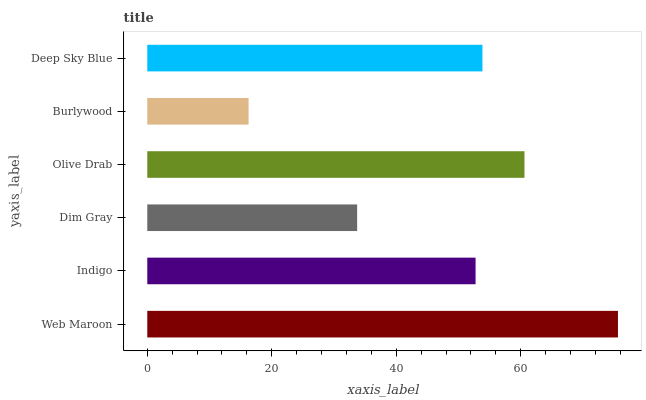Is Burlywood the minimum?
Answer yes or no. Yes. Is Web Maroon the maximum?
Answer yes or no. Yes. Is Indigo the minimum?
Answer yes or no. No. Is Indigo the maximum?
Answer yes or no. No. Is Web Maroon greater than Indigo?
Answer yes or no. Yes. Is Indigo less than Web Maroon?
Answer yes or no. Yes. Is Indigo greater than Web Maroon?
Answer yes or no. No. Is Web Maroon less than Indigo?
Answer yes or no. No. Is Deep Sky Blue the high median?
Answer yes or no. Yes. Is Indigo the low median?
Answer yes or no. Yes. Is Dim Gray the high median?
Answer yes or no. No. Is Web Maroon the low median?
Answer yes or no. No. 